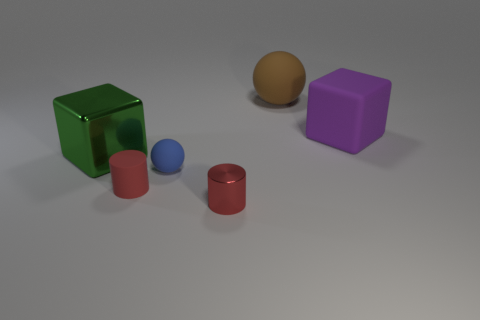What is the material of the big object that is to the left of the large object that is behind the cube behind the green object?
Provide a short and direct response. Metal. What number of objects are metal things or big matte balls?
Your response must be concise. 3. Is the color of the cylinder right of the small matte sphere the same as the cylinder that is behind the shiny cylinder?
Your answer should be compact. Yes. The red object that is the same size as the red matte cylinder is what shape?
Provide a succinct answer. Cylinder. What number of objects are small red cylinders in front of the large green metal thing or large purple things in front of the brown object?
Your answer should be compact. 3. Are there fewer big gray matte things than big shiny things?
Offer a terse response. Yes. What material is the other red object that is the same size as the red shiny object?
Make the answer very short. Rubber. There is a block that is to the right of the big brown ball; is it the same size as the thing that is behind the big purple cube?
Offer a terse response. Yes. Is there a blue ball that has the same material as the blue object?
Give a very brief answer. No. What number of things are either metal things right of the big green object or big red metal cylinders?
Provide a short and direct response. 1. 